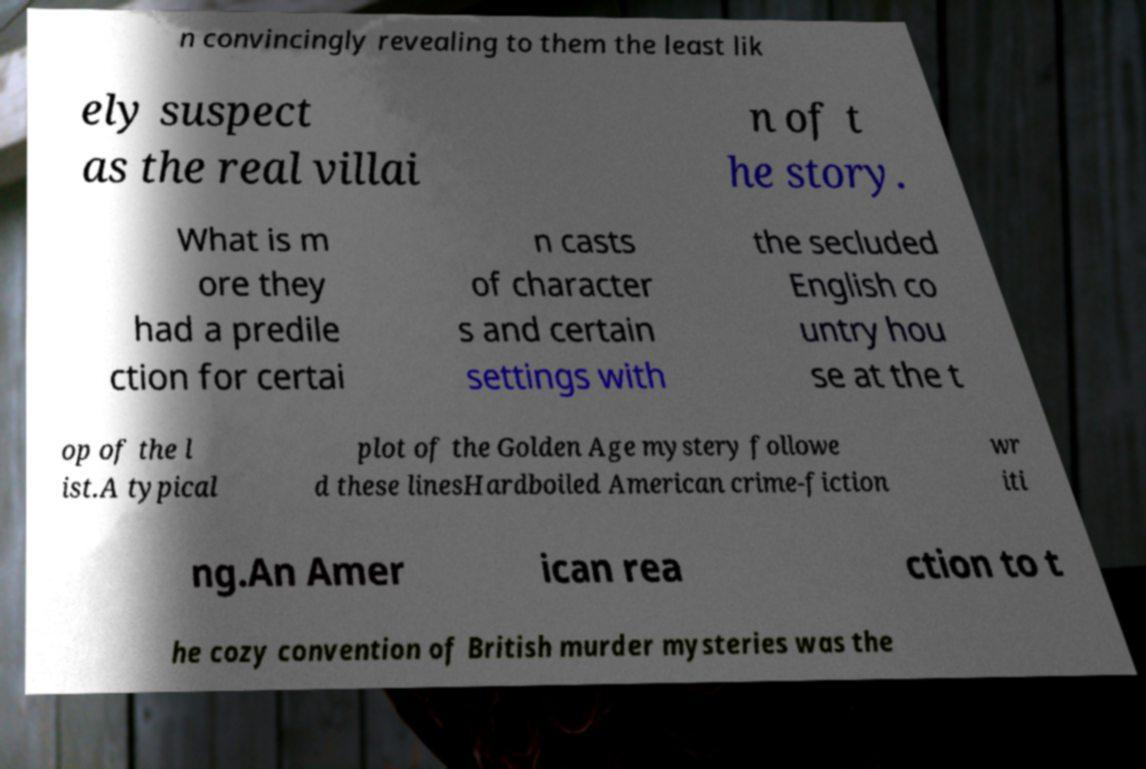Please read and relay the text visible in this image. What does it say? n convincingly revealing to them the least lik ely suspect as the real villai n of t he story. What is m ore they had a predile ction for certai n casts of character s and certain settings with the secluded English co untry hou se at the t op of the l ist.A typical plot of the Golden Age mystery followe d these linesHardboiled American crime-fiction wr iti ng.An Amer ican rea ction to t he cozy convention of British murder mysteries was the 